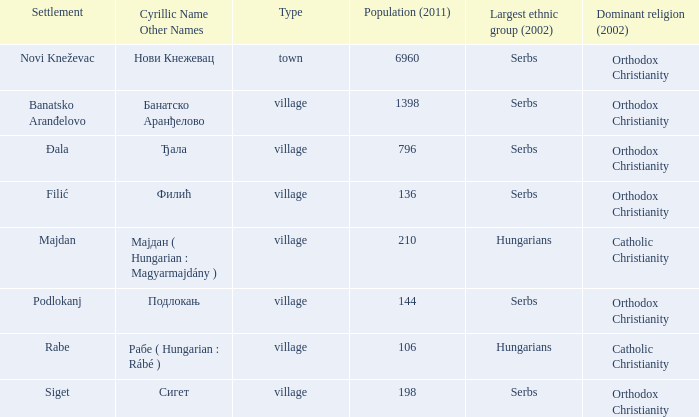What is the largest ethnic group of the settlement with the cyrillic name of банатско аранђелово? Serbs. 